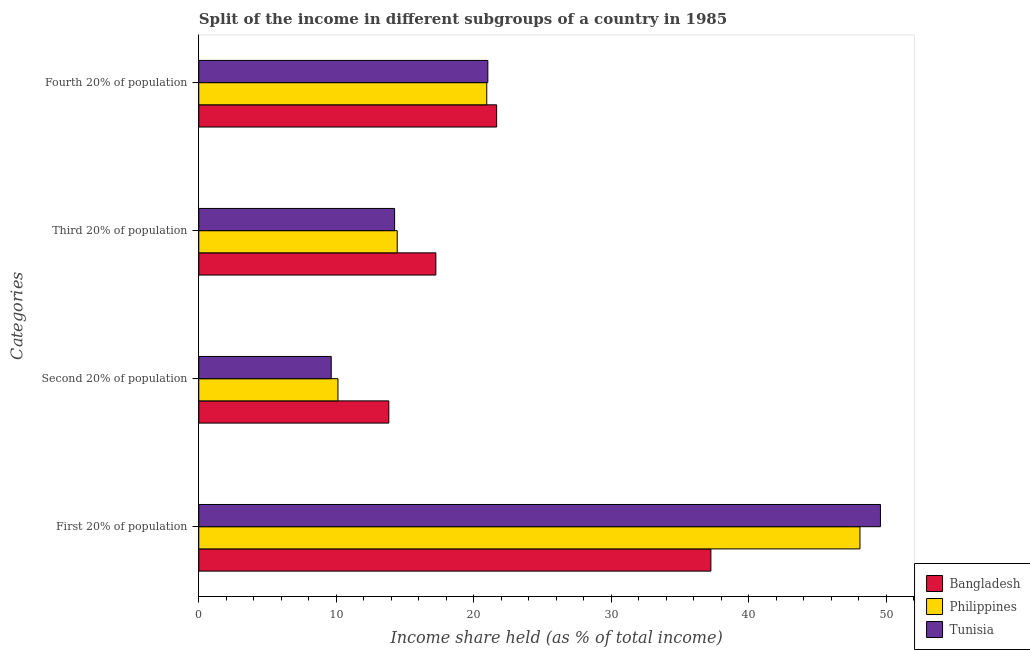How many different coloured bars are there?
Ensure brevity in your answer.  3. Are the number of bars on each tick of the Y-axis equal?
Offer a terse response. Yes. What is the label of the 4th group of bars from the top?
Keep it short and to the point. First 20% of population. What is the share of the income held by second 20% of the population in Bangladesh?
Ensure brevity in your answer.  13.82. Across all countries, what is the maximum share of the income held by first 20% of the population?
Provide a succinct answer. 49.57. Across all countries, what is the minimum share of the income held by third 20% of the population?
Your answer should be compact. 14.24. In which country was the share of the income held by second 20% of the population maximum?
Give a very brief answer. Bangladesh. What is the total share of the income held by fourth 20% of the population in the graph?
Ensure brevity in your answer.  63.62. What is the difference between the share of the income held by second 20% of the population in Bangladesh and that in Tunisia?
Offer a very short reply. 4.19. What is the difference between the share of the income held by third 20% of the population in Bangladesh and the share of the income held by fourth 20% of the population in Philippines?
Make the answer very short. -3.7. What is the average share of the income held by fourth 20% of the population per country?
Your response must be concise. 21.21. What is the difference between the share of the income held by second 20% of the population and share of the income held by fourth 20% of the population in Tunisia?
Provide a succinct answer. -11.39. In how many countries, is the share of the income held by first 20% of the population greater than 16 %?
Your response must be concise. 3. What is the ratio of the share of the income held by first 20% of the population in Bangladesh to that in Philippines?
Ensure brevity in your answer.  0.77. Is the difference between the share of the income held by first 20% of the population in Philippines and Bangladesh greater than the difference between the share of the income held by third 20% of the population in Philippines and Bangladesh?
Ensure brevity in your answer.  Yes. What is the difference between the highest and the second highest share of the income held by second 20% of the population?
Offer a terse response. 3.7. What is the difference between the highest and the lowest share of the income held by first 20% of the population?
Your answer should be very brief. 12.33. In how many countries, is the share of the income held by fourth 20% of the population greater than the average share of the income held by fourth 20% of the population taken over all countries?
Offer a terse response. 1. What does the 1st bar from the top in First 20% of population represents?
Ensure brevity in your answer.  Tunisia. How many bars are there?
Your answer should be compact. 12. What is the difference between two consecutive major ticks on the X-axis?
Keep it short and to the point. 10. Are the values on the major ticks of X-axis written in scientific E-notation?
Ensure brevity in your answer.  No. Where does the legend appear in the graph?
Your response must be concise. Bottom right. How many legend labels are there?
Keep it short and to the point. 3. What is the title of the graph?
Your answer should be very brief. Split of the income in different subgroups of a country in 1985. Does "Honduras" appear as one of the legend labels in the graph?
Ensure brevity in your answer.  No. What is the label or title of the X-axis?
Provide a short and direct response. Income share held (as % of total income). What is the label or title of the Y-axis?
Provide a short and direct response. Categories. What is the Income share held (as % of total income) of Bangladesh in First 20% of population?
Your response must be concise. 37.24. What is the Income share held (as % of total income) of Philippines in First 20% of population?
Make the answer very short. 48.08. What is the Income share held (as % of total income) in Tunisia in First 20% of population?
Ensure brevity in your answer.  49.57. What is the Income share held (as % of total income) in Bangladesh in Second 20% of population?
Provide a short and direct response. 13.82. What is the Income share held (as % of total income) in Philippines in Second 20% of population?
Keep it short and to the point. 10.12. What is the Income share held (as % of total income) of Tunisia in Second 20% of population?
Make the answer very short. 9.63. What is the Income share held (as % of total income) in Bangladesh in Third 20% of population?
Give a very brief answer. 17.24. What is the Income share held (as % of total income) of Philippines in Third 20% of population?
Give a very brief answer. 14.43. What is the Income share held (as % of total income) in Tunisia in Third 20% of population?
Keep it short and to the point. 14.24. What is the Income share held (as % of total income) of Bangladesh in Fourth 20% of population?
Give a very brief answer. 21.66. What is the Income share held (as % of total income) in Philippines in Fourth 20% of population?
Offer a very short reply. 20.94. What is the Income share held (as % of total income) in Tunisia in Fourth 20% of population?
Provide a succinct answer. 21.02. Across all Categories, what is the maximum Income share held (as % of total income) of Bangladesh?
Your answer should be very brief. 37.24. Across all Categories, what is the maximum Income share held (as % of total income) of Philippines?
Your answer should be very brief. 48.08. Across all Categories, what is the maximum Income share held (as % of total income) in Tunisia?
Your answer should be compact. 49.57. Across all Categories, what is the minimum Income share held (as % of total income) in Bangladesh?
Provide a succinct answer. 13.82. Across all Categories, what is the minimum Income share held (as % of total income) in Philippines?
Your answer should be very brief. 10.12. Across all Categories, what is the minimum Income share held (as % of total income) in Tunisia?
Make the answer very short. 9.63. What is the total Income share held (as % of total income) in Bangladesh in the graph?
Make the answer very short. 89.96. What is the total Income share held (as % of total income) of Philippines in the graph?
Your answer should be very brief. 93.57. What is the total Income share held (as % of total income) of Tunisia in the graph?
Your answer should be compact. 94.46. What is the difference between the Income share held (as % of total income) in Bangladesh in First 20% of population and that in Second 20% of population?
Offer a very short reply. 23.42. What is the difference between the Income share held (as % of total income) of Philippines in First 20% of population and that in Second 20% of population?
Give a very brief answer. 37.96. What is the difference between the Income share held (as % of total income) in Tunisia in First 20% of population and that in Second 20% of population?
Provide a short and direct response. 39.94. What is the difference between the Income share held (as % of total income) in Philippines in First 20% of population and that in Third 20% of population?
Offer a terse response. 33.65. What is the difference between the Income share held (as % of total income) of Tunisia in First 20% of population and that in Third 20% of population?
Offer a terse response. 35.33. What is the difference between the Income share held (as % of total income) in Bangladesh in First 20% of population and that in Fourth 20% of population?
Your response must be concise. 15.58. What is the difference between the Income share held (as % of total income) of Philippines in First 20% of population and that in Fourth 20% of population?
Ensure brevity in your answer.  27.14. What is the difference between the Income share held (as % of total income) in Tunisia in First 20% of population and that in Fourth 20% of population?
Your answer should be very brief. 28.55. What is the difference between the Income share held (as % of total income) of Bangladesh in Second 20% of population and that in Third 20% of population?
Ensure brevity in your answer.  -3.42. What is the difference between the Income share held (as % of total income) of Philippines in Second 20% of population and that in Third 20% of population?
Your answer should be very brief. -4.31. What is the difference between the Income share held (as % of total income) in Tunisia in Second 20% of population and that in Third 20% of population?
Provide a succinct answer. -4.61. What is the difference between the Income share held (as % of total income) in Bangladesh in Second 20% of population and that in Fourth 20% of population?
Provide a short and direct response. -7.84. What is the difference between the Income share held (as % of total income) in Philippines in Second 20% of population and that in Fourth 20% of population?
Your answer should be compact. -10.82. What is the difference between the Income share held (as % of total income) in Tunisia in Second 20% of population and that in Fourth 20% of population?
Offer a terse response. -11.39. What is the difference between the Income share held (as % of total income) of Bangladesh in Third 20% of population and that in Fourth 20% of population?
Your answer should be very brief. -4.42. What is the difference between the Income share held (as % of total income) in Philippines in Third 20% of population and that in Fourth 20% of population?
Offer a very short reply. -6.51. What is the difference between the Income share held (as % of total income) in Tunisia in Third 20% of population and that in Fourth 20% of population?
Your answer should be very brief. -6.78. What is the difference between the Income share held (as % of total income) in Bangladesh in First 20% of population and the Income share held (as % of total income) in Philippines in Second 20% of population?
Keep it short and to the point. 27.12. What is the difference between the Income share held (as % of total income) of Bangladesh in First 20% of population and the Income share held (as % of total income) of Tunisia in Second 20% of population?
Offer a terse response. 27.61. What is the difference between the Income share held (as % of total income) in Philippines in First 20% of population and the Income share held (as % of total income) in Tunisia in Second 20% of population?
Make the answer very short. 38.45. What is the difference between the Income share held (as % of total income) of Bangladesh in First 20% of population and the Income share held (as % of total income) of Philippines in Third 20% of population?
Offer a terse response. 22.81. What is the difference between the Income share held (as % of total income) in Philippines in First 20% of population and the Income share held (as % of total income) in Tunisia in Third 20% of population?
Make the answer very short. 33.84. What is the difference between the Income share held (as % of total income) in Bangladesh in First 20% of population and the Income share held (as % of total income) in Tunisia in Fourth 20% of population?
Your answer should be very brief. 16.22. What is the difference between the Income share held (as % of total income) in Philippines in First 20% of population and the Income share held (as % of total income) in Tunisia in Fourth 20% of population?
Provide a short and direct response. 27.06. What is the difference between the Income share held (as % of total income) in Bangladesh in Second 20% of population and the Income share held (as % of total income) in Philippines in Third 20% of population?
Ensure brevity in your answer.  -0.61. What is the difference between the Income share held (as % of total income) in Bangladesh in Second 20% of population and the Income share held (as % of total income) in Tunisia in Third 20% of population?
Give a very brief answer. -0.42. What is the difference between the Income share held (as % of total income) in Philippines in Second 20% of population and the Income share held (as % of total income) in Tunisia in Third 20% of population?
Provide a succinct answer. -4.12. What is the difference between the Income share held (as % of total income) of Bangladesh in Second 20% of population and the Income share held (as % of total income) of Philippines in Fourth 20% of population?
Give a very brief answer. -7.12. What is the difference between the Income share held (as % of total income) in Bangladesh in Third 20% of population and the Income share held (as % of total income) in Tunisia in Fourth 20% of population?
Ensure brevity in your answer.  -3.78. What is the difference between the Income share held (as % of total income) in Philippines in Third 20% of population and the Income share held (as % of total income) in Tunisia in Fourth 20% of population?
Keep it short and to the point. -6.59. What is the average Income share held (as % of total income) in Bangladesh per Categories?
Give a very brief answer. 22.49. What is the average Income share held (as % of total income) of Philippines per Categories?
Your response must be concise. 23.39. What is the average Income share held (as % of total income) of Tunisia per Categories?
Provide a succinct answer. 23.61. What is the difference between the Income share held (as % of total income) of Bangladesh and Income share held (as % of total income) of Philippines in First 20% of population?
Offer a very short reply. -10.84. What is the difference between the Income share held (as % of total income) in Bangladesh and Income share held (as % of total income) in Tunisia in First 20% of population?
Offer a very short reply. -12.33. What is the difference between the Income share held (as % of total income) of Philippines and Income share held (as % of total income) of Tunisia in First 20% of population?
Your answer should be compact. -1.49. What is the difference between the Income share held (as % of total income) of Bangladesh and Income share held (as % of total income) of Tunisia in Second 20% of population?
Offer a terse response. 4.19. What is the difference between the Income share held (as % of total income) in Philippines and Income share held (as % of total income) in Tunisia in Second 20% of population?
Provide a succinct answer. 0.49. What is the difference between the Income share held (as % of total income) of Bangladesh and Income share held (as % of total income) of Philippines in Third 20% of population?
Provide a short and direct response. 2.81. What is the difference between the Income share held (as % of total income) of Philippines and Income share held (as % of total income) of Tunisia in Third 20% of population?
Provide a succinct answer. 0.19. What is the difference between the Income share held (as % of total income) of Bangladesh and Income share held (as % of total income) of Philippines in Fourth 20% of population?
Your response must be concise. 0.72. What is the difference between the Income share held (as % of total income) of Bangladesh and Income share held (as % of total income) of Tunisia in Fourth 20% of population?
Keep it short and to the point. 0.64. What is the difference between the Income share held (as % of total income) of Philippines and Income share held (as % of total income) of Tunisia in Fourth 20% of population?
Ensure brevity in your answer.  -0.08. What is the ratio of the Income share held (as % of total income) of Bangladesh in First 20% of population to that in Second 20% of population?
Provide a short and direct response. 2.69. What is the ratio of the Income share held (as % of total income) of Philippines in First 20% of population to that in Second 20% of population?
Offer a very short reply. 4.75. What is the ratio of the Income share held (as % of total income) of Tunisia in First 20% of population to that in Second 20% of population?
Provide a succinct answer. 5.15. What is the ratio of the Income share held (as % of total income) of Bangladesh in First 20% of population to that in Third 20% of population?
Your answer should be compact. 2.16. What is the ratio of the Income share held (as % of total income) in Philippines in First 20% of population to that in Third 20% of population?
Keep it short and to the point. 3.33. What is the ratio of the Income share held (as % of total income) in Tunisia in First 20% of population to that in Third 20% of population?
Provide a succinct answer. 3.48. What is the ratio of the Income share held (as % of total income) of Bangladesh in First 20% of population to that in Fourth 20% of population?
Make the answer very short. 1.72. What is the ratio of the Income share held (as % of total income) in Philippines in First 20% of population to that in Fourth 20% of population?
Give a very brief answer. 2.3. What is the ratio of the Income share held (as % of total income) of Tunisia in First 20% of population to that in Fourth 20% of population?
Your answer should be very brief. 2.36. What is the ratio of the Income share held (as % of total income) in Bangladesh in Second 20% of population to that in Third 20% of population?
Give a very brief answer. 0.8. What is the ratio of the Income share held (as % of total income) of Philippines in Second 20% of population to that in Third 20% of population?
Keep it short and to the point. 0.7. What is the ratio of the Income share held (as % of total income) of Tunisia in Second 20% of population to that in Third 20% of population?
Make the answer very short. 0.68. What is the ratio of the Income share held (as % of total income) in Bangladesh in Second 20% of population to that in Fourth 20% of population?
Your answer should be very brief. 0.64. What is the ratio of the Income share held (as % of total income) in Philippines in Second 20% of population to that in Fourth 20% of population?
Offer a terse response. 0.48. What is the ratio of the Income share held (as % of total income) in Tunisia in Second 20% of population to that in Fourth 20% of population?
Provide a succinct answer. 0.46. What is the ratio of the Income share held (as % of total income) in Bangladesh in Third 20% of population to that in Fourth 20% of population?
Give a very brief answer. 0.8. What is the ratio of the Income share held (as % of total income) of Philippines in Third 20% of population to that in Fourth 20% of population?
Offer a very short reply. 0.69. What is the ratio of the Income share held (as % of total income) of Tunisia in Third 20% of population to that in Fourth 20% of population?
Your answer should be very brief. 0.68. What is the difference between the highest and the second highest Income share held (as % of total income) of Bangladesh?
Make the answer very short. 15.58. What is the difference between the highest and the second highest Income share held (as % of total income) in Philippines?
Ensure brevity in your answer.  27.14. What is the difference between the highest and the second highest Income share held (as % of total income) in Tunisia?
Keep it short and to the point. 28.55. What is the difference between the highest and the lowest Income share held (as % of total income) in Bangladesh?
Your answer should be very brief. 23.42. What is the difference between the highest and the lowest Income share held (as % of total income) of Philippines?
Your answer should be very brief. 37.96. What is the difference between the highest and the lowest Income share held (as % of total income) of Tunisia?
Make the answer very short. 39.94. 